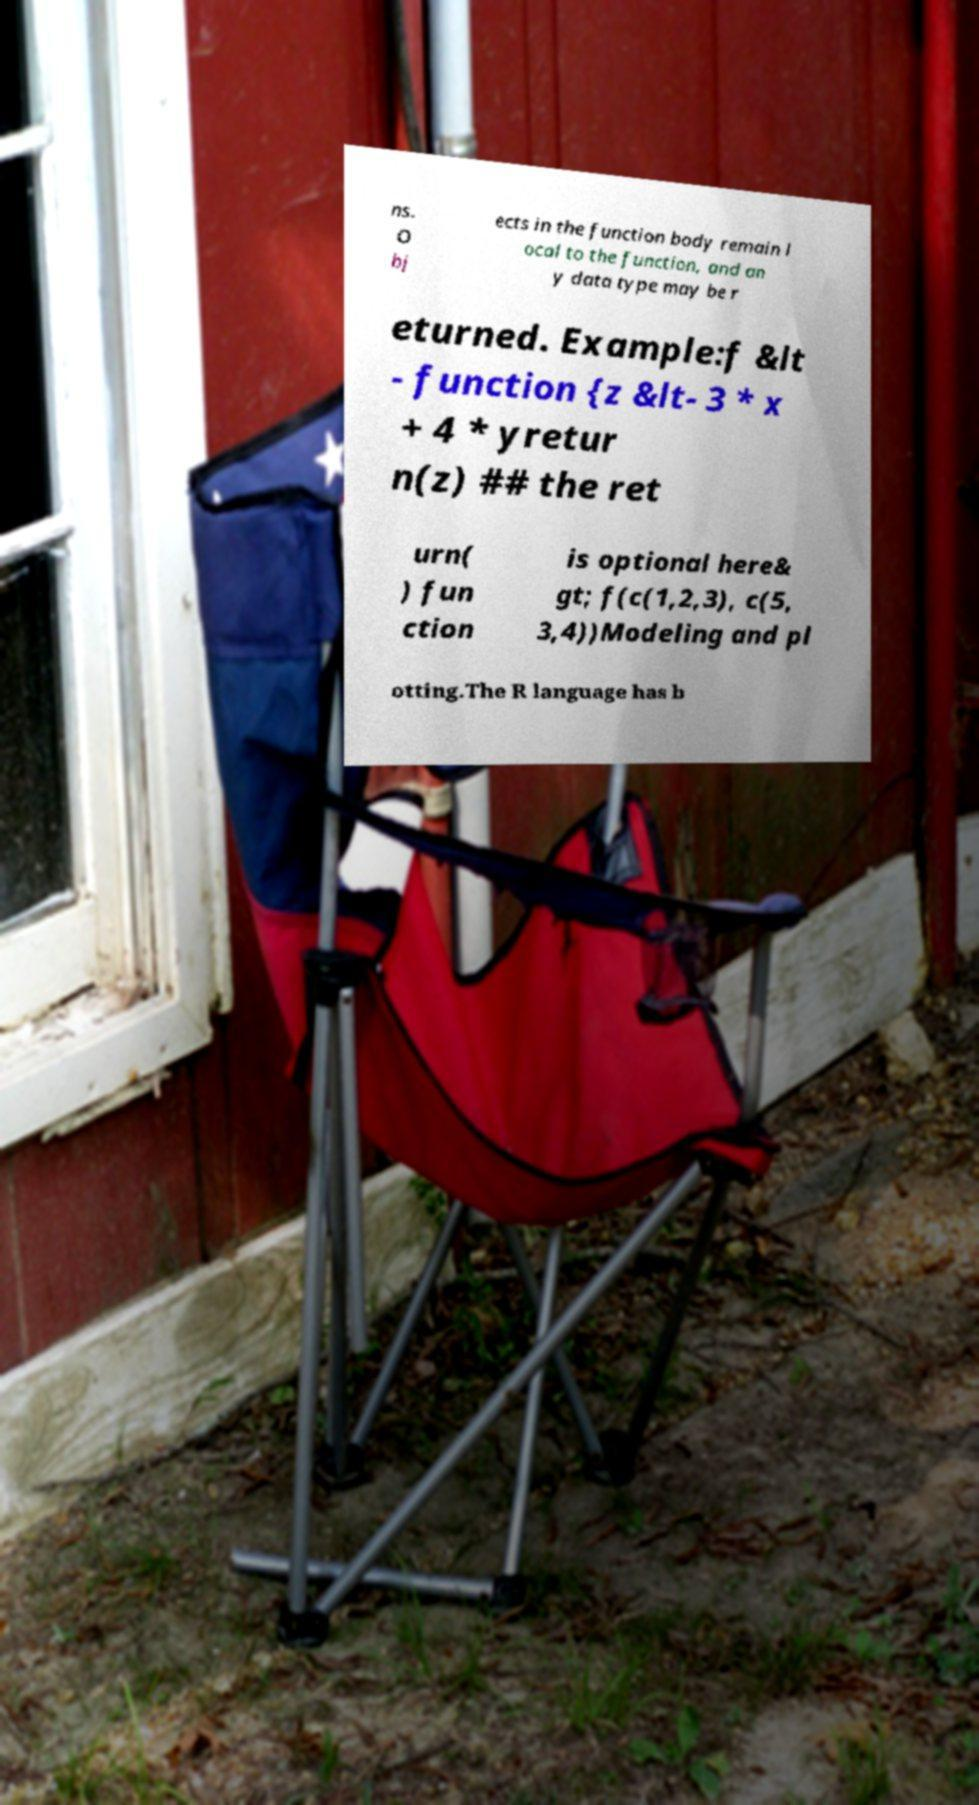For documentation purposes, I need the text within this image transcribed. Could you provide that? ns. O bj ects in the function body remain l ocal to the function, and an y data type may be r eturned. Example:f &lt - function {z &lt- 3 * x + 4 * yretur n(z) ## the ret urn( ) fun ction is optional here& gt; f(c(1,2,3), c(5, 3,4))Modeling and pl otting.The R language has b 